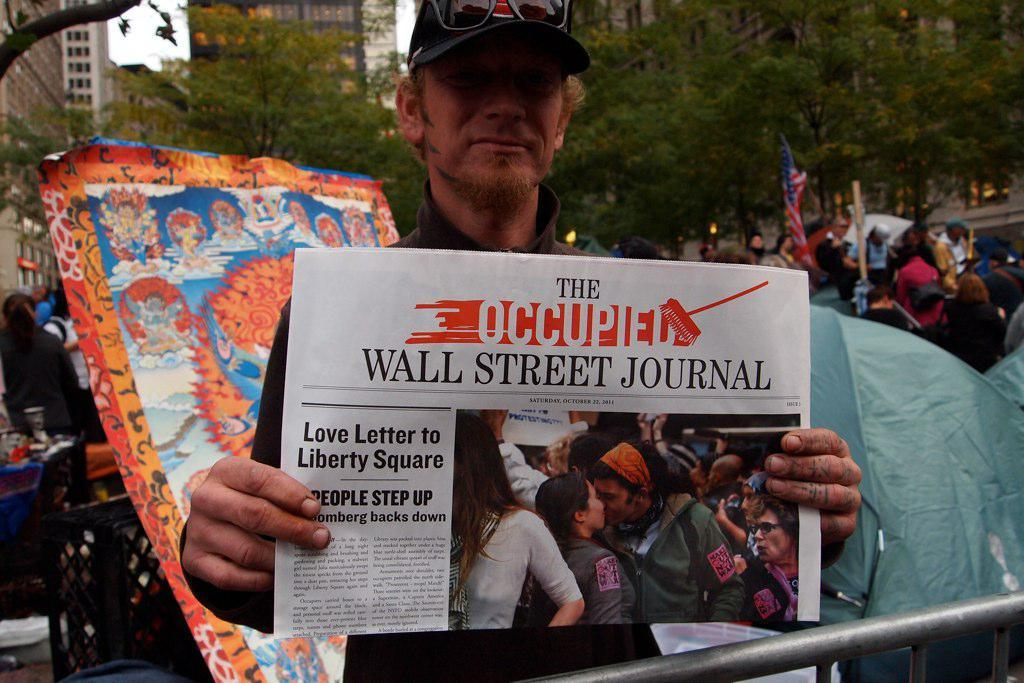<image>
Give a short and clear explanation of the subsequent image. a newspaper that says The Occupied Wall Street Journal 